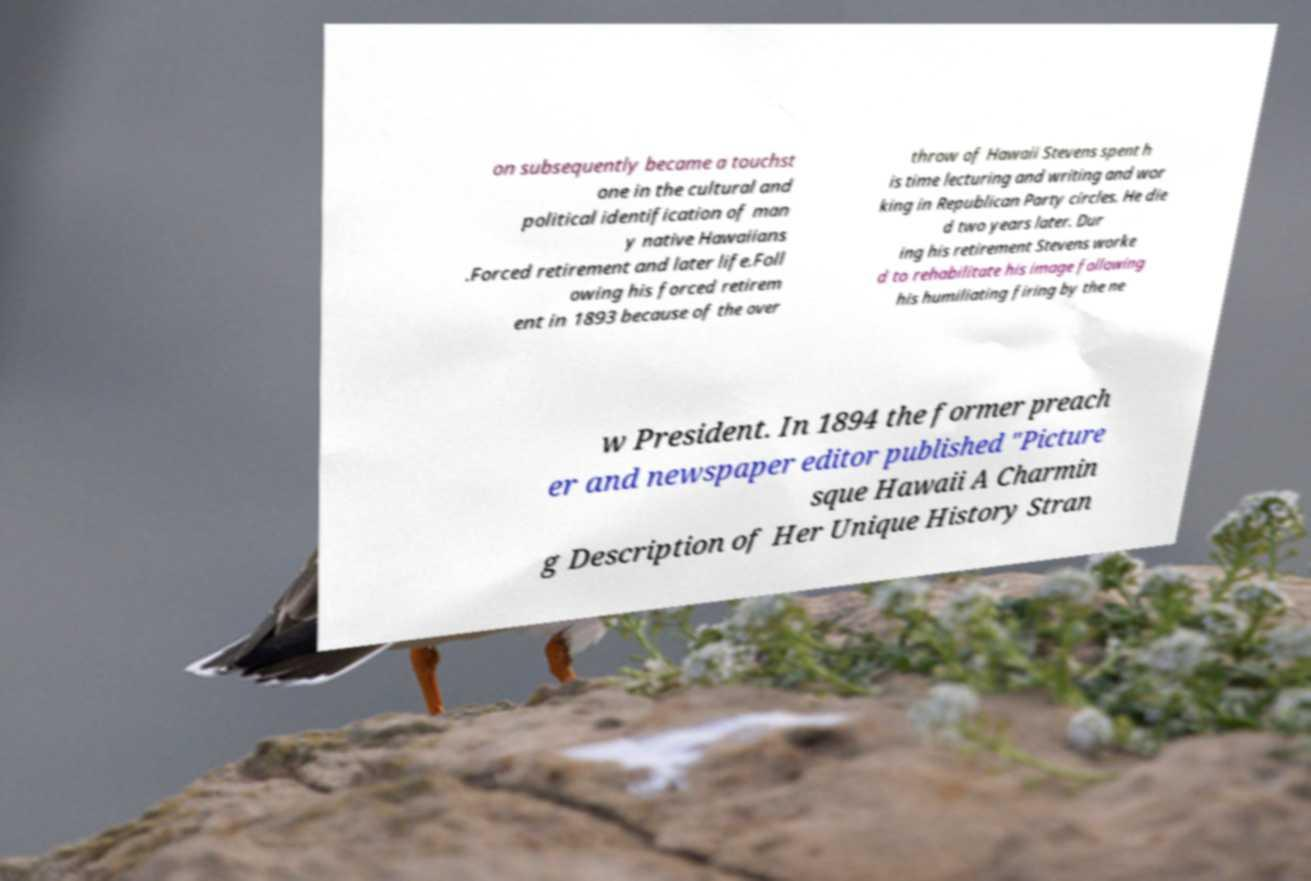Can you accurately transcribe the text from the provided image for me? on subsequently became a touchst one in the cultural and political identification of man y native Hawaiians .Forced retirement and later life.Foll owing his forced retirem ent in 1893 because of the over throw of Hawaii Stevens spent h is time lecturing and writing and wor king in Republican Party circles. He die d two years later. Dur ing his retirement Stevens worke d to rehabilitate his image following his humiliating firing by the ne w President. In 1894 the former preach er and newspaper editor published "Picture sque Hawaii A Charmin g Description of Her Unique History Stran 